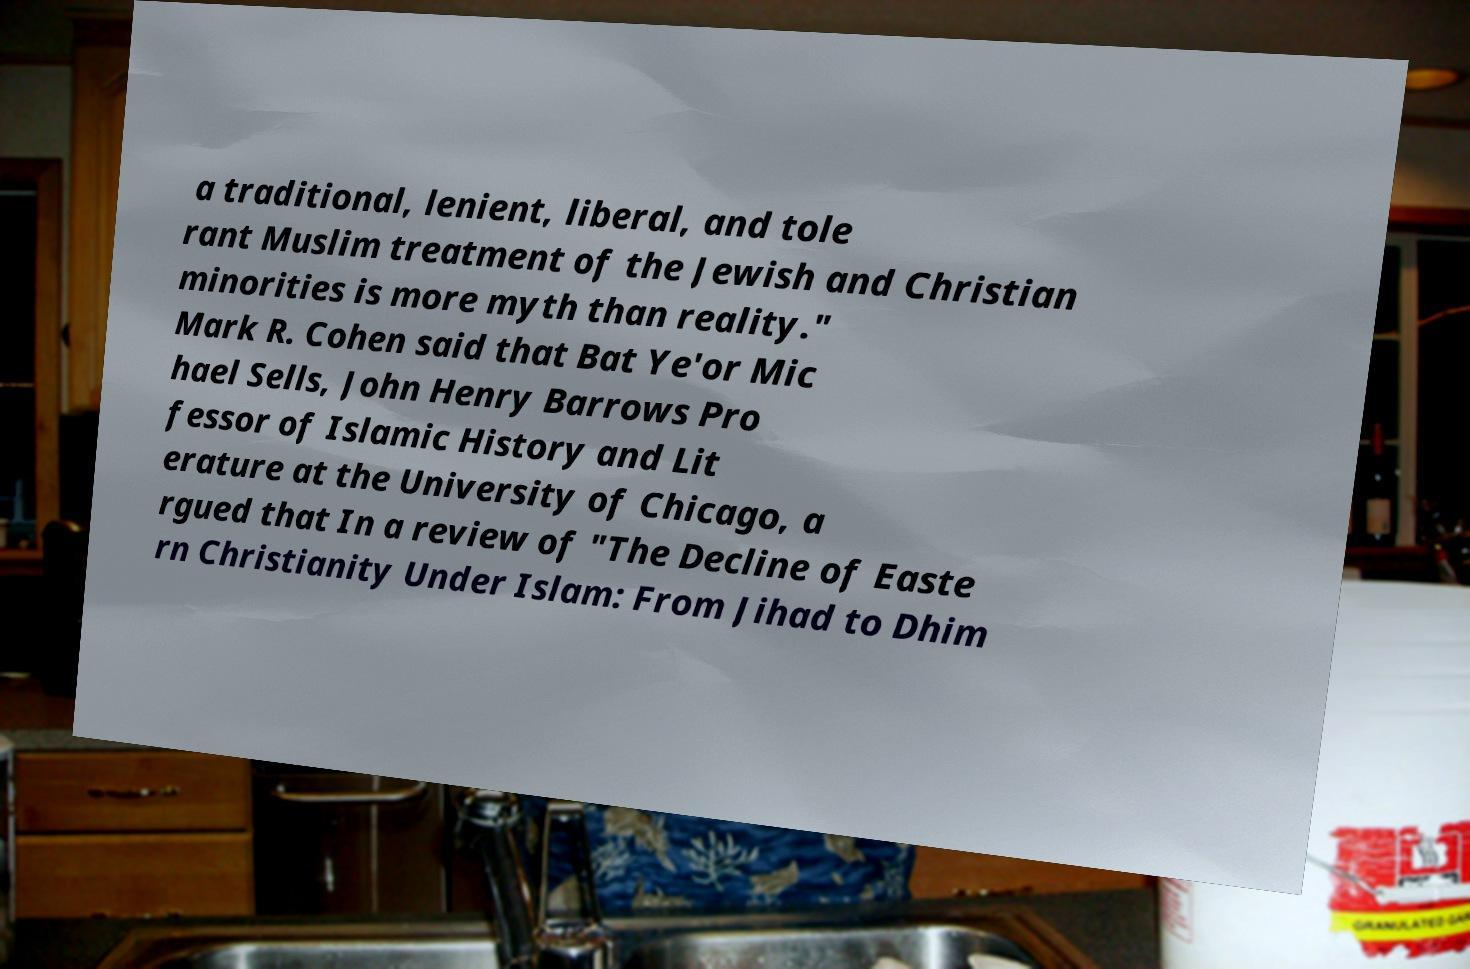Please identify and transcribe the text found in this image. a traditional, lenient, liberal, and tole rant Muslim treatment of the Jewish and Christian minorities is more myth than reality." Mark R. Cohen said that Bat Ye'or Mic hael Sells, John Henry Barrows Pro fessor of Islamic History and Lit erature at the University of Chicago, a rgued that In a review of "The Decline of Easte rn Christianity Under Islam: From Jihad to Dhim 